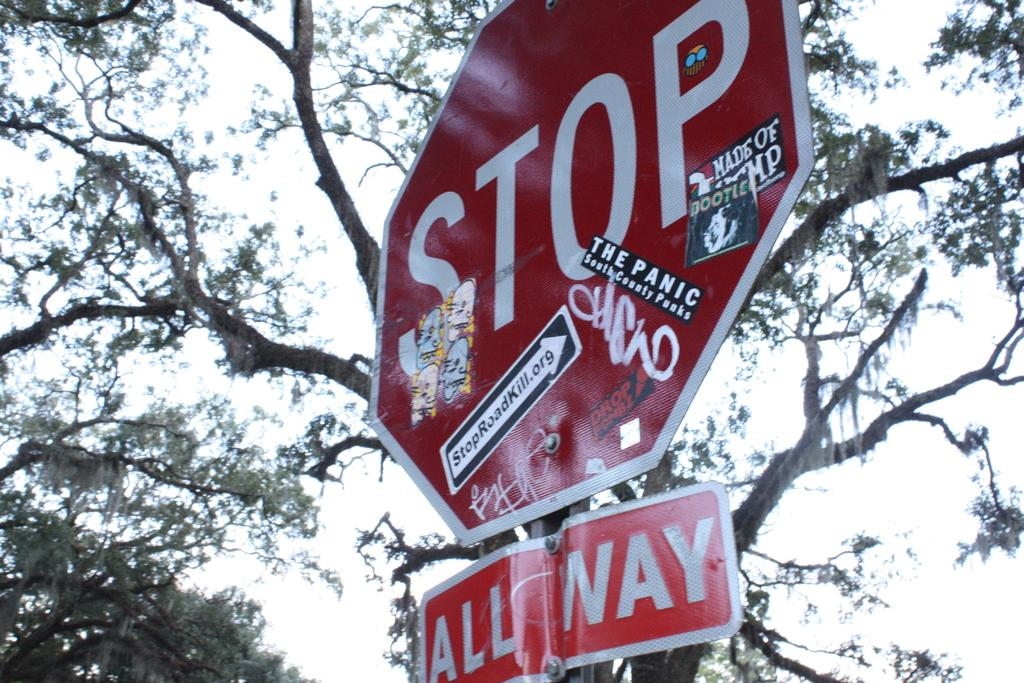<image>
Write a terse but informative summary of the picture. A red stop sign is covered in activist stickers. 